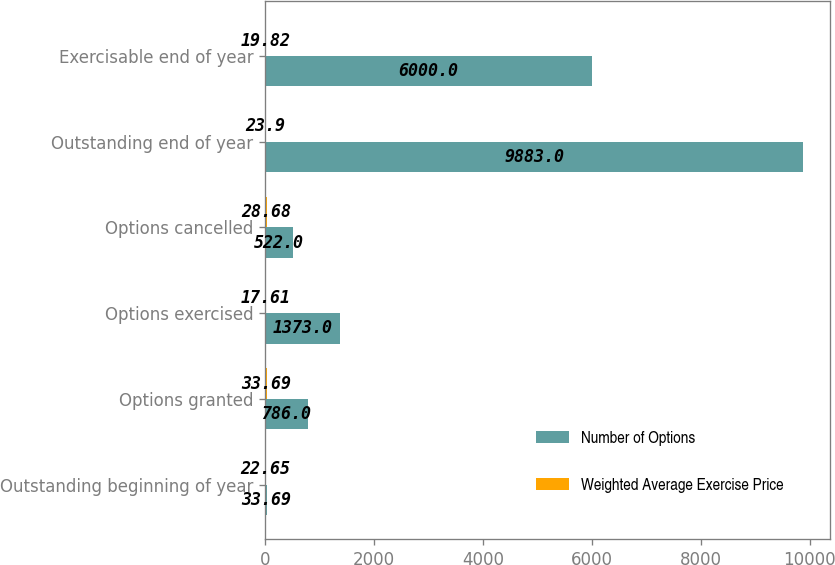Convert chart. <chart><loc_0><loc_0><loc_500><loc_500><stacked_bar_chart><ecel><fcel>Outstanding beginning of year<fcel>Options granted<fcel>Options exercised<fcel>Options cancelled<fcel>Outstanding end of year<fcel>Exercisable end of year<nl><fcel>Number of Options<fcel>33.69<fcel>786<fcel>1373<fcel>522<fcel>9883<fcel>6000<nl><fcel>Weighted Average Exercise Price<fcel>22.65<fcel>33.69<fcel>17.61<fcel>28.68<fcel>23.9<fcel>19.82<nl></chart> 